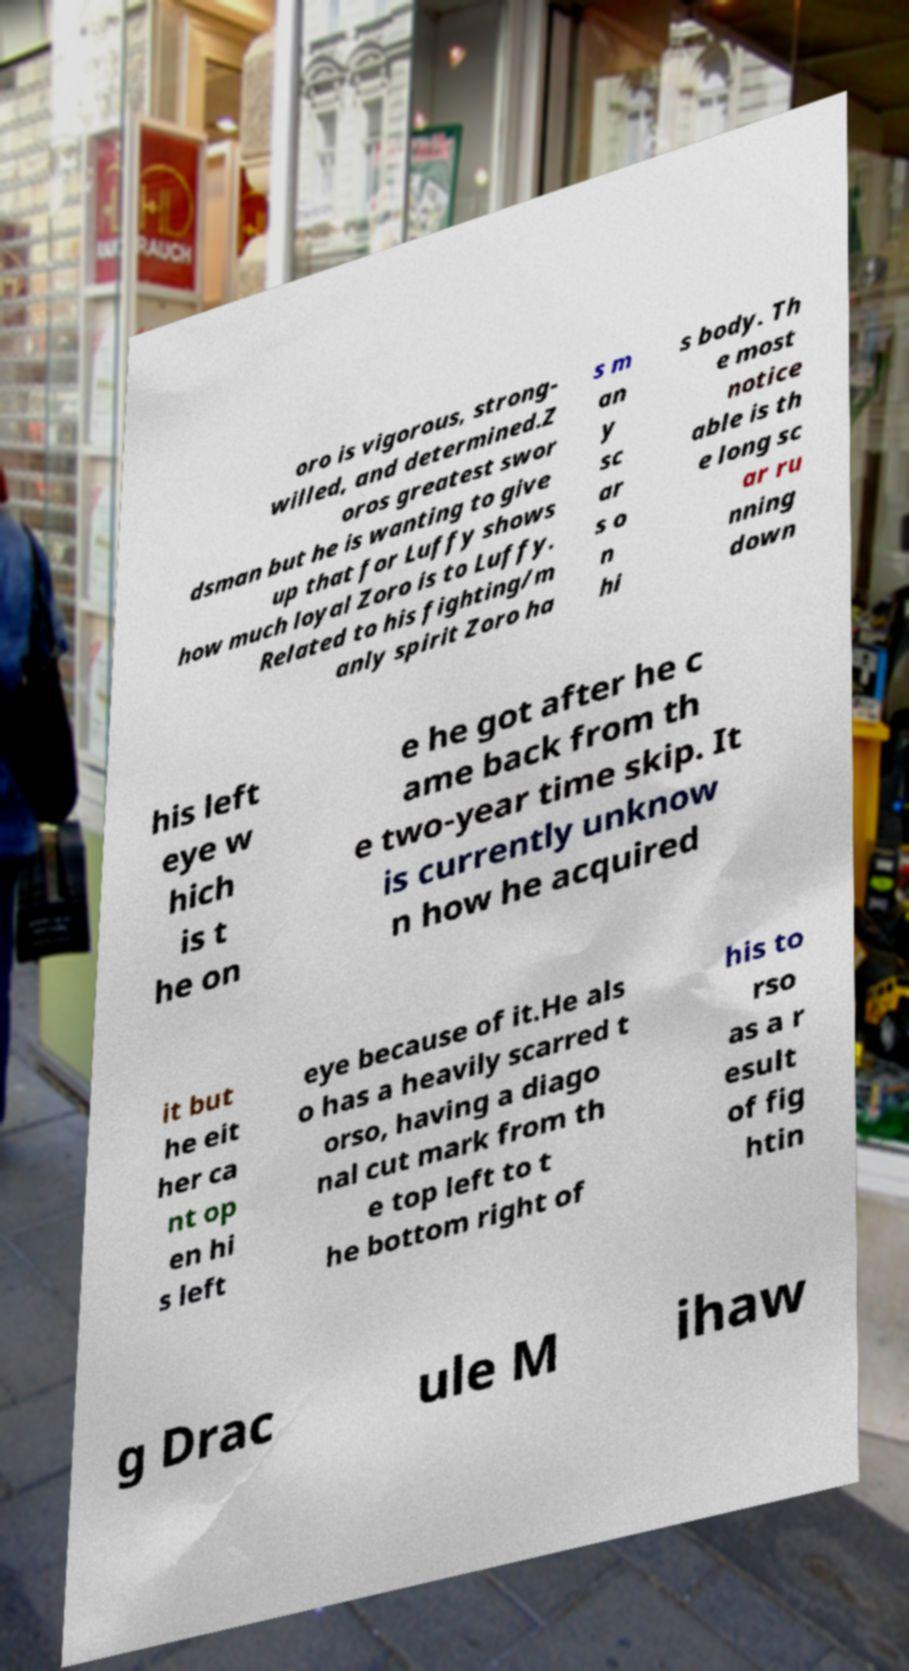Please identify and transcribe the text found in this image. oro is vigorous, strong- willed, and determined.Z oros greatest swor dsman but he is wanting to give up that for Luffy shows how much loyal Zoro is to Luffy. Related to his fighting/m anly spirit Zoro ha s m an y sc ar s o n hi s body. Th e most notice able is th e long sc ar ru nning down his left eye w hich is t he on e he got after he c ame back from th e two-year time skip. It is currently unknow n how he acquired it but he eit her ca nt op en hi s left eye because of it.He als o has a heavily scarred t orso, having a diago nal cut mark from th e top left to t he bottom right of his to rso as a r esult of fig htin g Drac ule M ihaw 